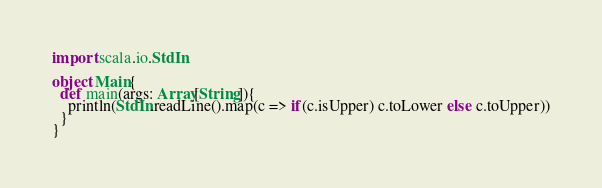Convert code to text. <code><loc_0><loc_0><loc_500><loc_500><_Scala_>import scala.io.StdIn

object Main{
  def main(args: Array[String]){
    println(StdIn.readLine().map(c => if(c.isUpper) c.toLower else c.toUpper))
  }
}</code> 